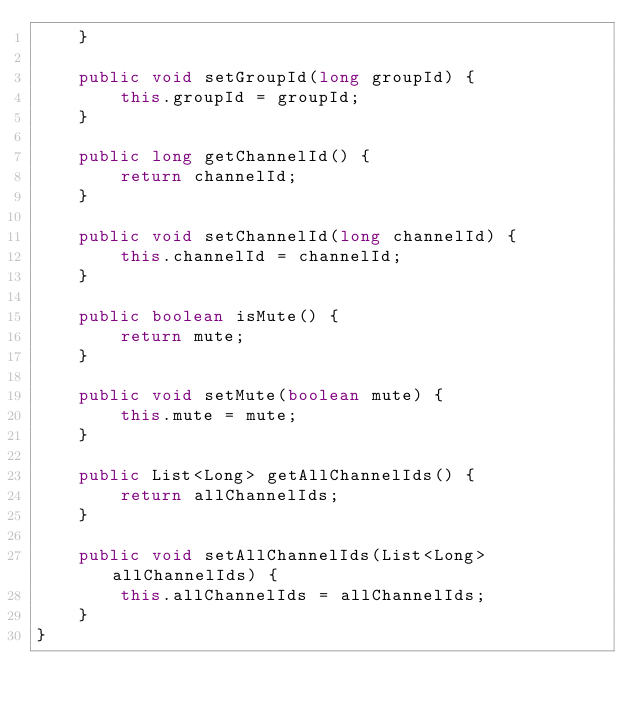<code> <loc_0><loc_0><loc_500><loc_500><_Java_>    }

    public void setGroupId(long groupId) {
        this.groupId = groupId;
    }

    public long getChannelId() {
        return channelId;
    }

    public void setChannelId(long channelId) {
        this.channelId = channelId;
    }

    public boolean isMute() {
        return mute;
    }

    public void setMute(boolean mute) {
        this.mute = mute;
    }

    public List<Long> getAllChannelIds() {
        return allChannelIds;
    }

    public void setAllChannelIds(List<Long> allChannelIds) {
        this.allChannelIds = allChannelIds;
    }
}
</code> 